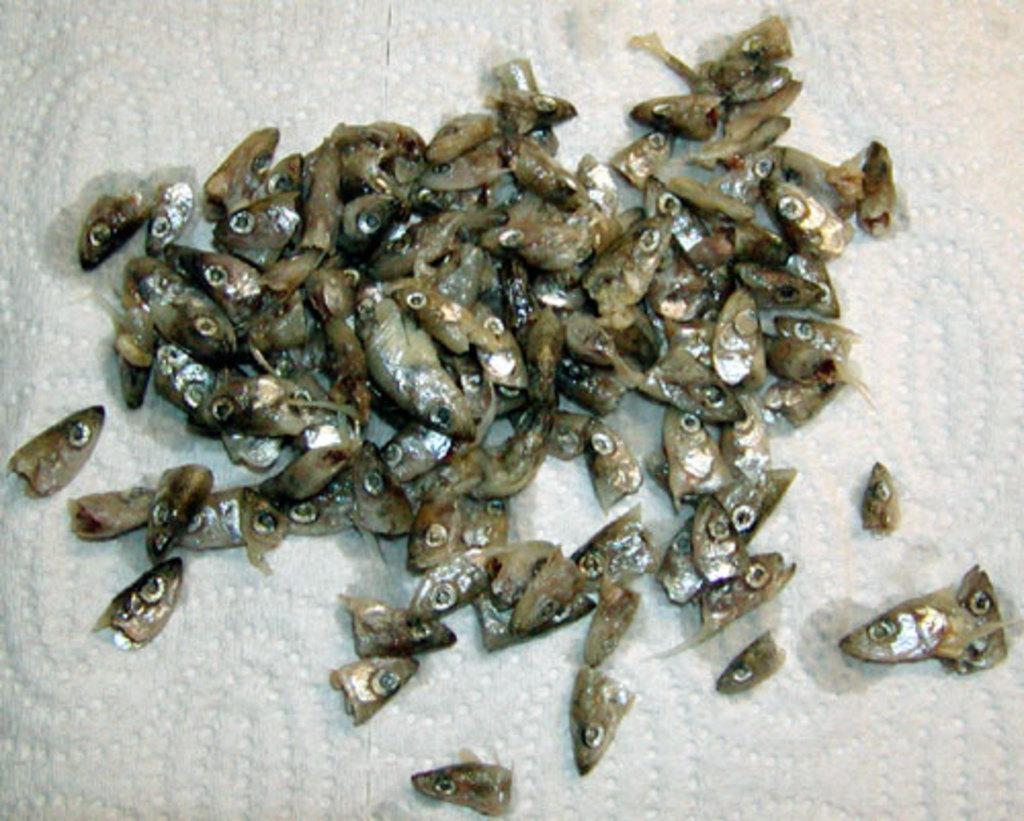What type of animal parts are visible in the image? There are fish heads in the image. What is the color of the surface on which the fish heads are placed? The surface is white-colored. Can you see a person riding a roll on the train in the image? There is no person, roll, or train present in the image. 